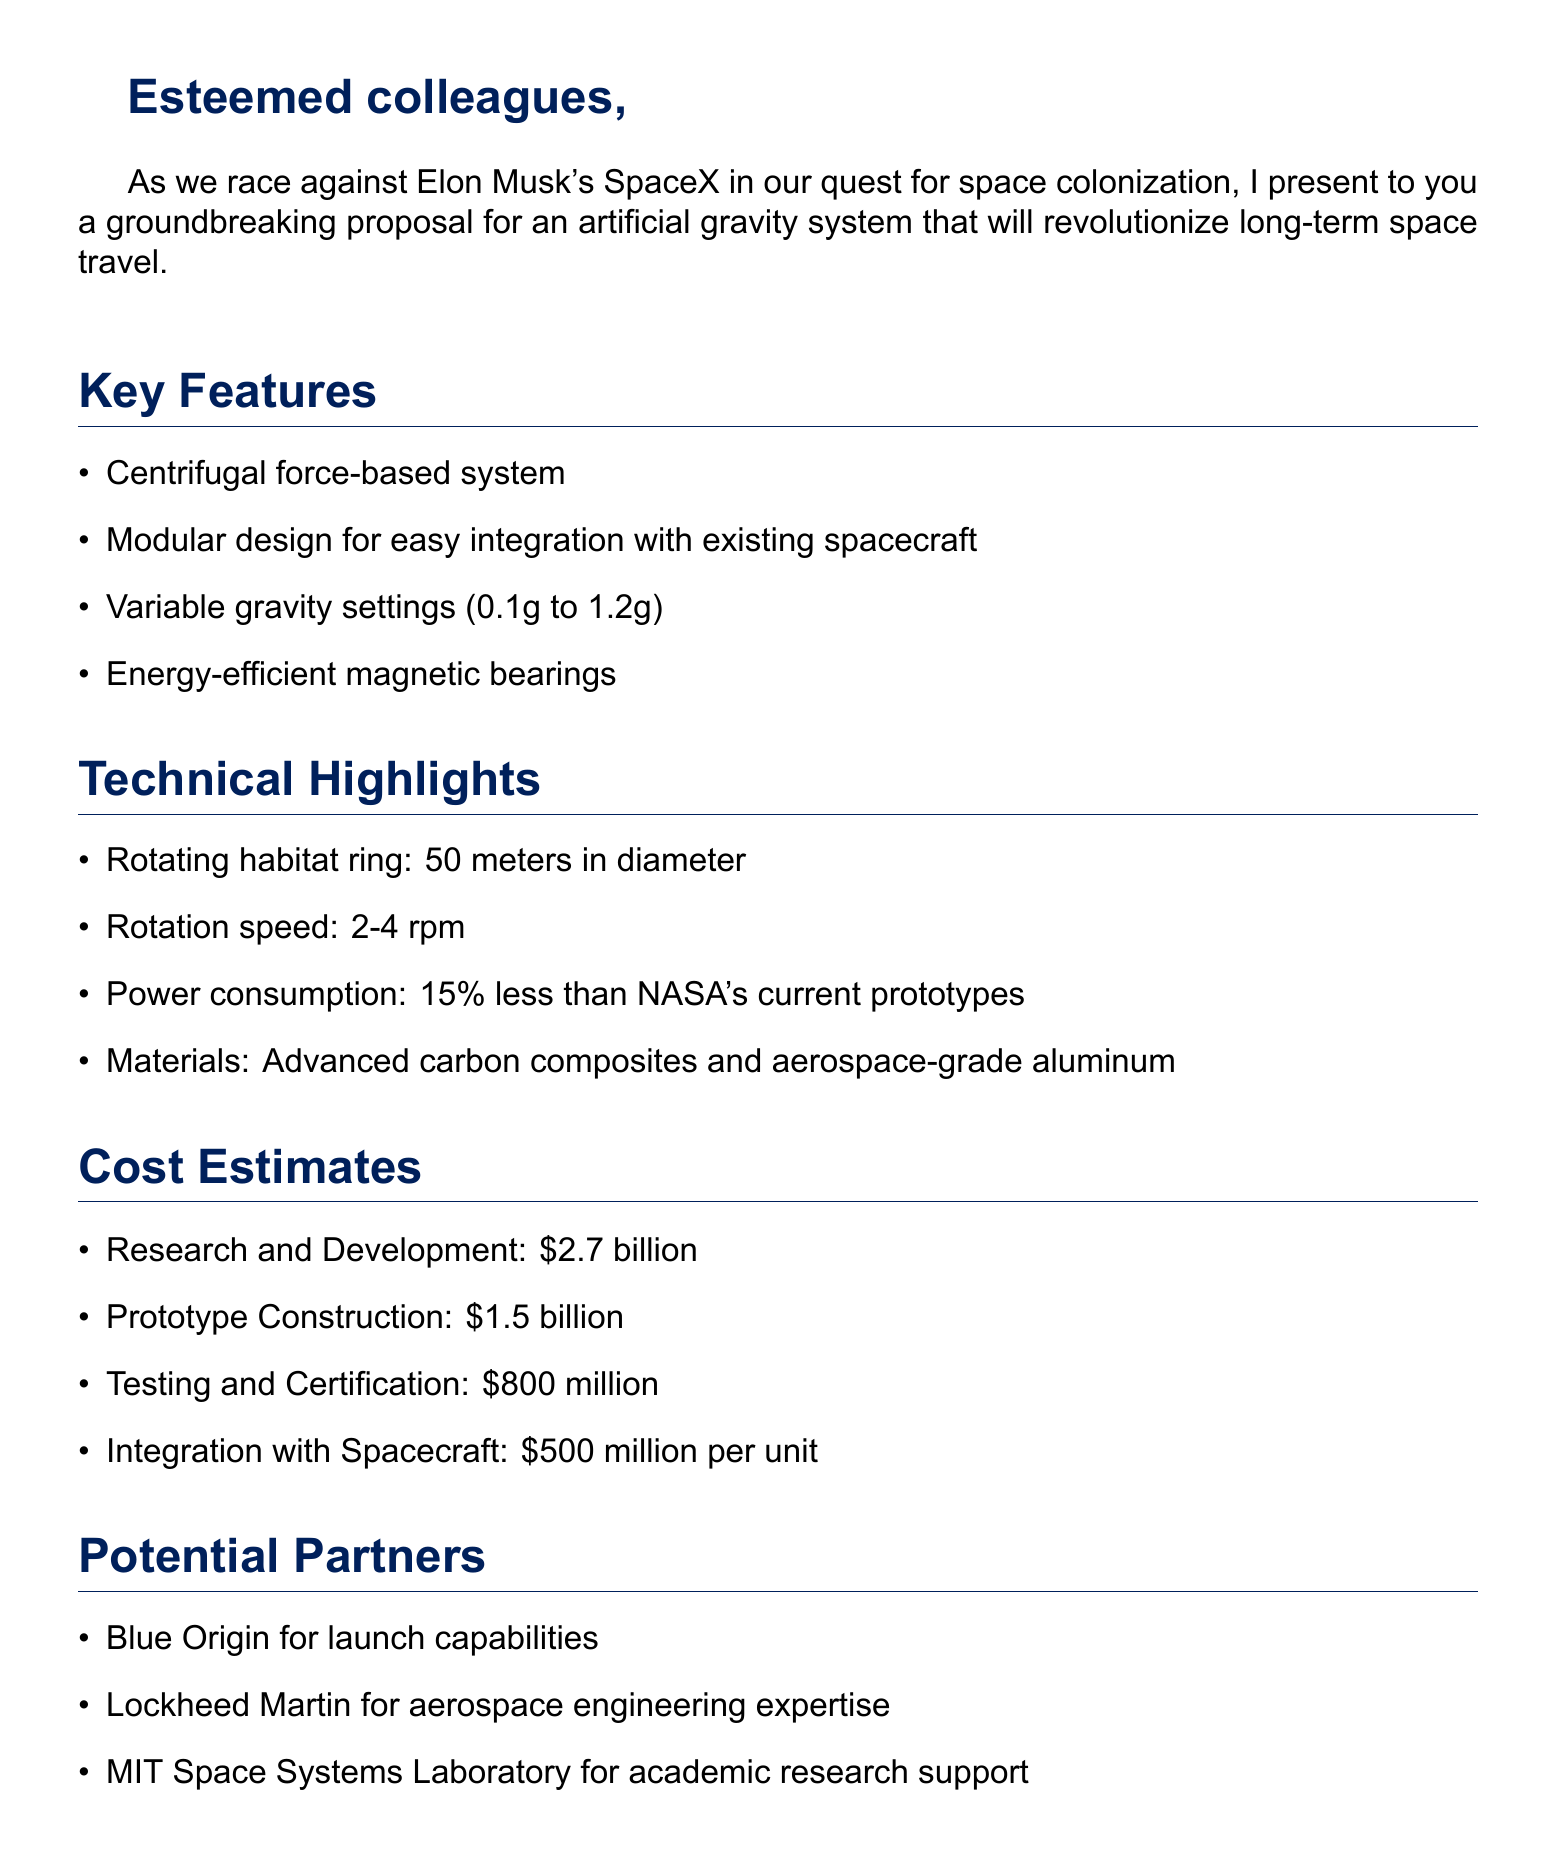What is the key technology used for the artificial gravity system? The proposal indicates that the key technology is a centrifugal force-based system.
Answer: Centrifugal force-based system What is the diameter of the rotating habitat ring? The document states that the rotating habitat ring measures 50 meters in diameter.
Answer: 50 meters How much is estimated for research and development? The document provides a cost estimate of $2.7 billion for research and development.
Answer: $2.7 billion What is the maximum variable gravity setting? According to the document, the maximum variable gravity setting is 1.2g.
Answer: 1.2g What is the power consumption reduction compared to NASA's prototypes? The proposal mentions a power consumption reduction of 15% less than NASA's current prototypes.
Answer: 15% Name one potential partner for the project. The document lists potential partners, one of which is Blue Origin.
Answer: Blue Origin How much is the total investment proposed by the author? The author is prepared to invest a total of $10 billion in the project.
Answer: $10 billion What materials are highlighted for the system's construction? The document highlights advanced carbon composites and aerospace-grade aluminum as materials.
Answer: Advanced carbon composites and aerospace-grade aluminum What is the integration cost per unit? The integration cost with the spacecraft is estimated at $500 million per unit.
Answer: $500 million per unit 